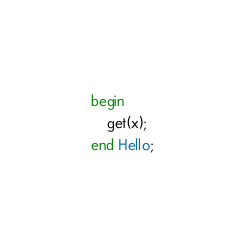<code> <loc_0><loc_0><loc_500><loc_500><_Ada_>begin
    get(x);
end Hello;</code> 